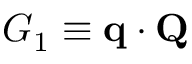Convert formula to latex. <formula><loc_0><loc_0><loc_500><loc_500>G _ { 1 } \equiv q \cdot Q</formula> 